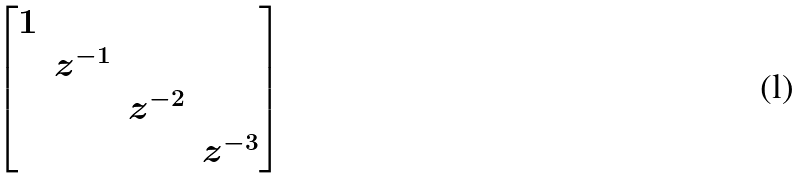Convert formula to latex. <formula><loc_0><loc_0><loc_500><loc_500>\begin{bmatrix} 1 & & & \\ & z ^ { - 1 } & & \\ & & z ^ { - 2 } & \\ & & & z ^ { - 3 } \end{bmatrix}</formula> 